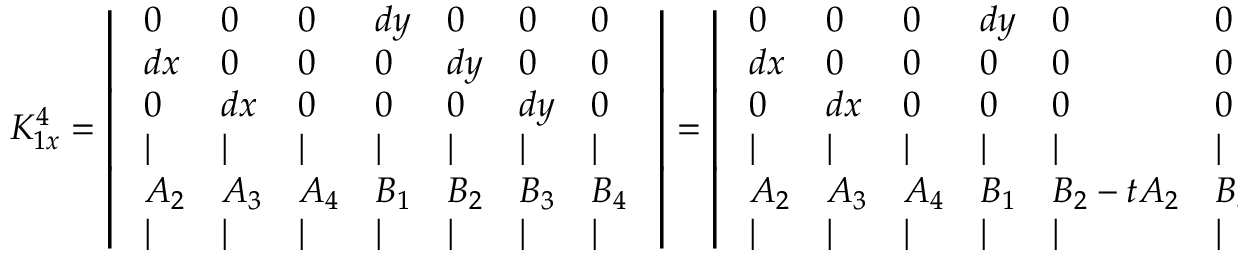<formula> <loc_0><loc_0><loc_500><loc_500>K _ { 1 x } ^ { 4 } = \left | \begin{array} { l l l l l l l } { 0 } & { 0 } & { 0 } & { d y } & { 0 } & { 0 } & { 0 } \\ { d x } & { 0 } & { 0 } & { 0 } & { d y } & { 0 } & { 0 } \\ { 0 } & { d x } & { 0 } & { 0 } & { 0 } & { d y } & { 0 } \\ { | } & { | } & { | } & { | } & { | } & { | } & { | } \\ { A _ { 2 } } & { A _ { 3 } } & { A _ { 4 } } & { B _ { 1 } } & { B _ { 2 } } & { B _ { 3 } } & { B _ { 4 } } \\ { | } & { | } & { | } & { | } & { | } & { | } & { | } \end{array} \right | = \left | \begin{array} { l l l l l l l } { 0 } & { 0 } & { 0 } & { d y } & { 0 } & { 0 } & { 0 } \\ { d x } & { 0 } & { 0 } & { 0 } & { 0 } & { 0 } & { 0 } \\ { 0 } & { d x } & { 0 } & { 0 } & { 0 } & { 0 } & { 0 } \\ { | } & { | } & { | } & { | } & { | } & { | } & { | } \\ { A _ { 2 } } & { A _ { 3 } } & { A _ { 4 } } & { B _ { 1 } } & { B _ { 2 } - t A _ { 2 } } & { B _ { 3 } - t A _ { 3 } } & { B _ { 4 } } \\ { | } & { | } & { | } & { | } & { | } & { | } & { | } \end{array} \right |</formula> 